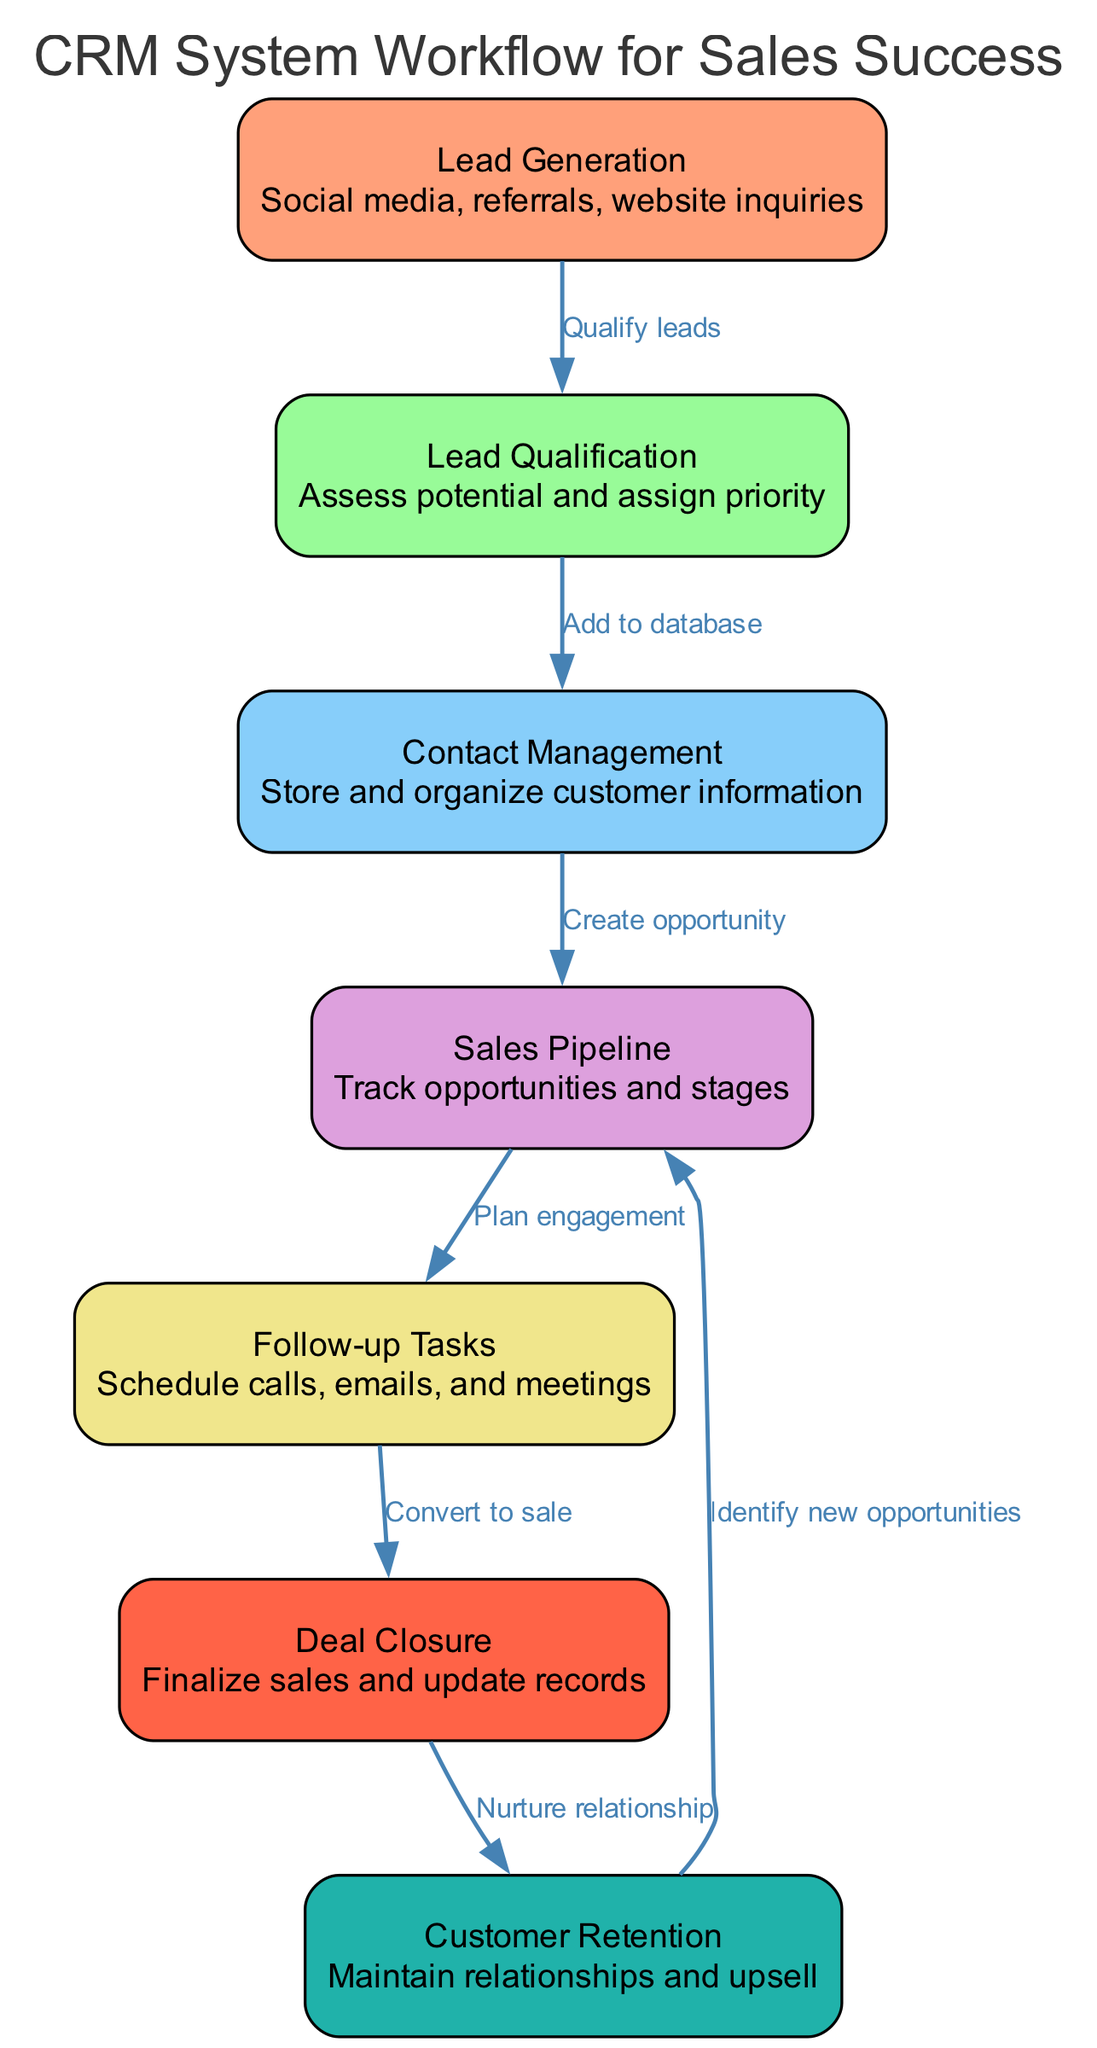What is the first step in the CRM system workflow? The diagram shows that the first step, or node, is "Lead Generation." This is identified as the starting point of the workflow.
Answer: Lead Generation How many nodes are there in the diagram? By counting the distinct nodes listed in the diagram, we find that there are seven nodes total, each representing a specific stage in the CRM process.
Answer: 7 Which node follows "Lead Qualification"? According to the edges connecting the nodes, "Lead Qualification" connects to "Contact Management," indicating that this is the next step in the workflow after qualifying leads.
Answer: Contact Management What action is taken after "Follow-up Tasks"? The diagram indicates that after "Follow-up Tasks," the next action is "Deal Closure." The edge connecting these two nodes shows this progression in the CRM workflow.
Answer: Deal Closure What node leads to "Customer Retention"? The diagram illustrates that "Deal Closure" is the preceding node that connects directly to "Customer Retention," indicating that maintaining relationships comes after finalizing sales.
Answer: Deal Closure Which two nodes are directly related to the "Sales Pipeline"? "Contact Management" feeds into "Sales Pipeline" and "Sales Pipeline" then directs to "Follow-up Tasks." Therefore, "Contact Management" and "Follow-up Tasks" are the two nodes directly related to it.
Answer: Contact Management, Follow-up Tasks After "Customer Retention," which node indicates a potential transition back into the sales process? The diagram shows that after "Customer Retention," there is a connection back to "Sales Pipeline," indicating that identifying new opportunities is a recurring part of the workflow.
Answer: Sales Pipeline What is the primary purpose of "Lead Generation" in the workflow? The first step's description states that "Lead Generation" involves acquiring potential customers through various channels, such as social media and referrals; thus, its primary purpose is to attract leads.
Answer: Attract leads What is the last phase of the CRM workflow diagram? The final node in the processed workflow, according to the diagram, is "Customer Retention," which signifies the ongoing relationship management after a sale.
Answer: Customer Retention 